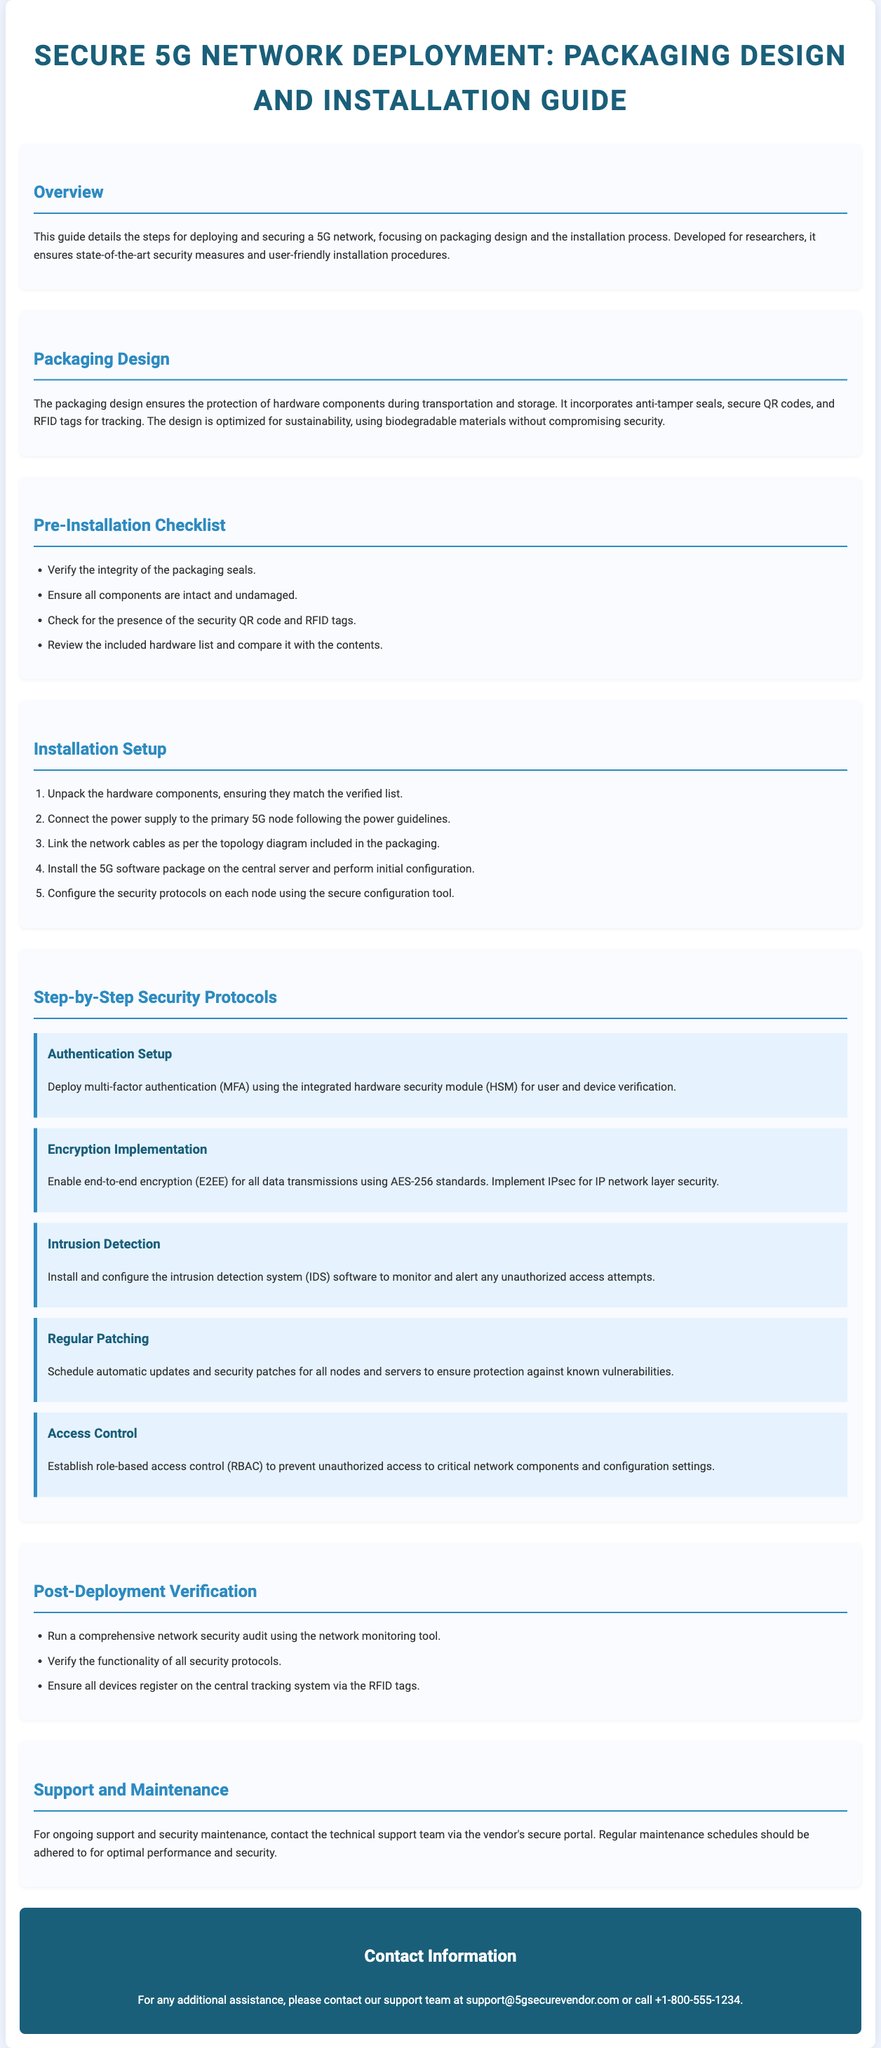What is the title of the document? The title of the document is the main heading found at the top of the page.
Answer: Secure 5G Network Deployment: Packaging Design and Installation Guide What color is used for the section headings? The color used for the section headings is specified in the style for the h2 elements in the document.
Answer: #2e8bc0 How many steps are in the installation setup? The number of steps can be counted in the installation setup section of the document.
Answer: 5 What is the first item in the pre-installation checklist? The first item is found in the list of pre-installation checklist items.
Answer: Verify the integrity of the packaging seals What security protocol is related to user and device verification? This security protocol is detailed under the step-by-step security protocols section, specifically focusing on authentication.
Answer: Authentication Setup Which encryption standard should be implemented? The encryption standard is mentioned in the encryption implementation section of the security protocols.
Answer: AES-256 How can ongoing support be accessed? The access method for ongoing support is described in the support and maintenance section of the document.
Answer: Vendor's secure portal What is the last item in the post-deployment verification? The last item in the list can be found in the post-deployment verification section of the document.
Answer: Ensure all devices register on the central tracking system via the RFID tags 